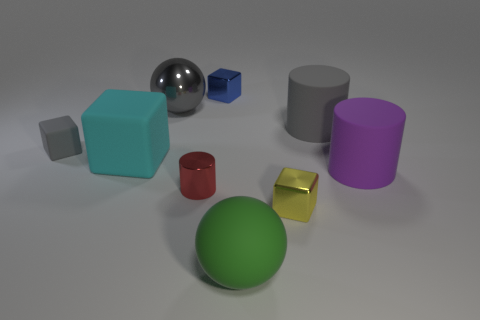Which objects in the image could be weighted to calibrate a scale? The metal sphere and the gold-colored cube seem to have a consistent density and could potentially serve as calibration weights for a scale, given their regular shapes and material quality. 